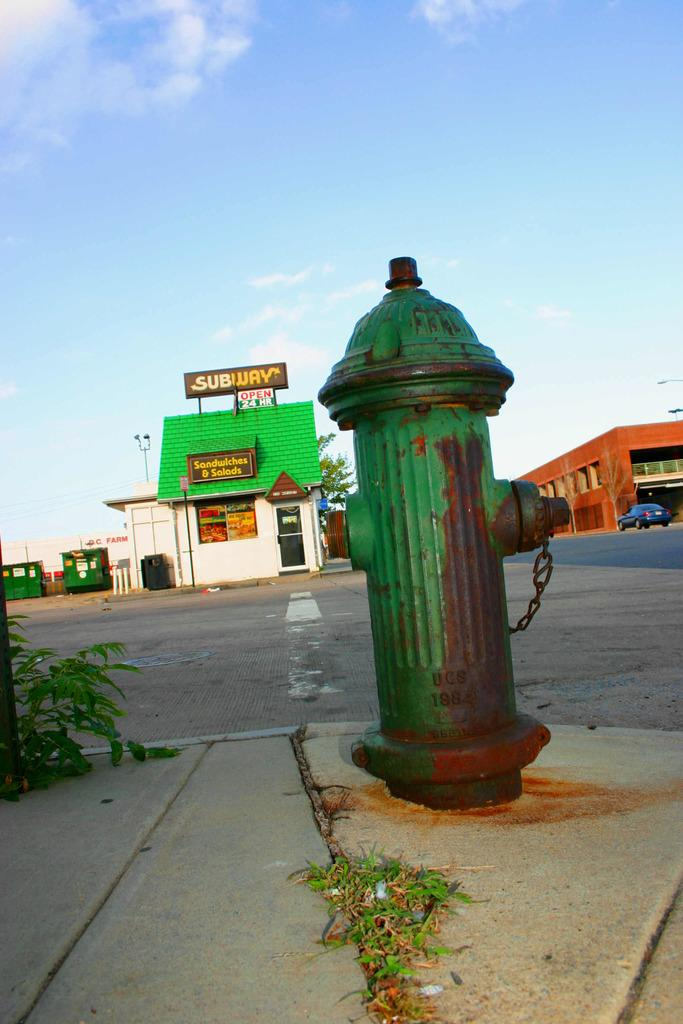Provide a one-sentence caption for the provided image. A green fire hydrant is outside of an old Subway restaurant. 